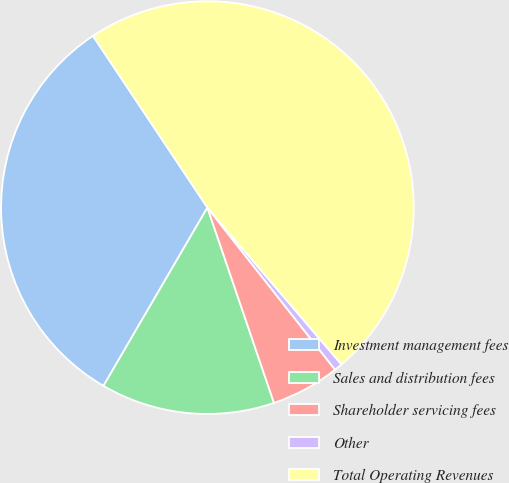Convert chart to OTSL. <chart><loc_0><loc_0><loc_500><loc_500><pie_chart><fcel>Investment management fees<fcel>Sales and distribution fees<fcel>Shareholder servicing fees<fcel>Other<fcel>Total Operating Revenues<nl><fcel>32.24%<fcel>13.63%<fcel>5.39%<fcel>0.64%<fcel>48.1%<nl></chart> 